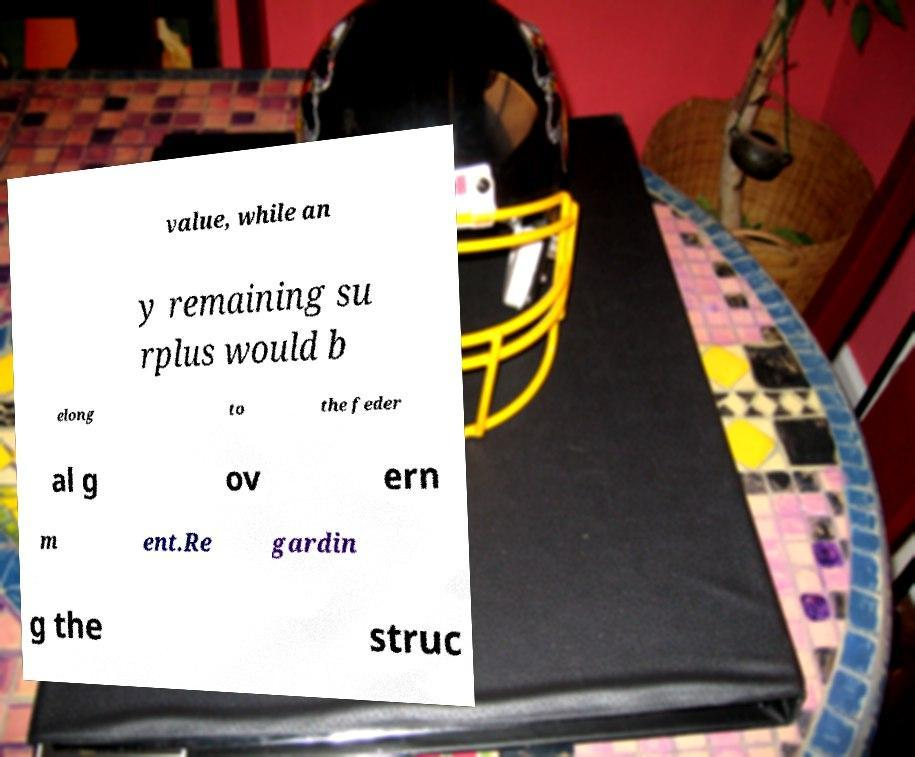Please identify and transcribe the text found in this image. value, while an y remaining su rplus would b elong to the feder al g ov ern m ent.Re gardin g the struc 